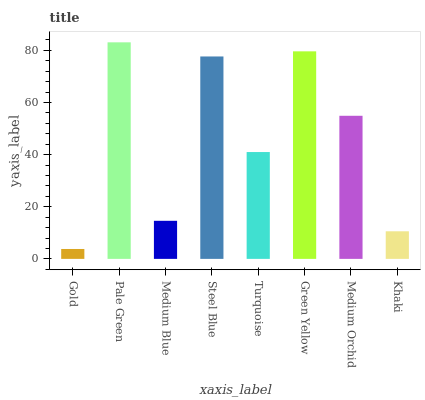Is Gold the minimum?
Answer yes or no. Yes. Is Pale Green the maximum?
Answer yes or no. Yes. Is Medium Blue the minimum?
Answer yes or no. No. Is Medium Blue the maximum?
Answer yes or no. No. Is Pale Green greater than Medium Blue?
Answer yes or no. Yes. Is Medium Blue less than Pale Green?
Answer yes or no. Yes. Is Medium Blue greater than Pale Green?
Answer yes or no. No. Is Pale Green less than Medium Blue?
Answer yes or no. No. Is Medium Orchid the high median?
Answer yes or no. Yes. Is Turquoise the low median?
Answer yes or no. Yes. Is Gold the high median?
Answer yes or no. No. Is Medium Orchid the low median?
Answer yes or no. No. 